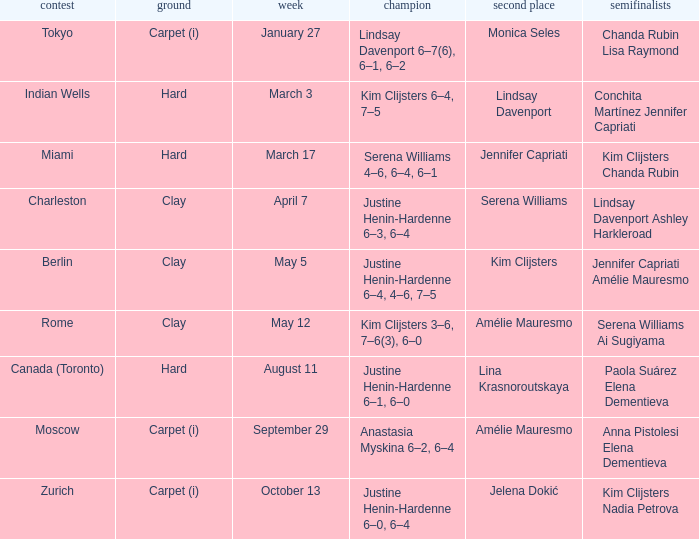Who was the winner against finalist Lina Krasnoroutskaya? Justine Henin-Hardenne 6–1, 6–0. 